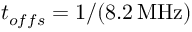<formula> <loc_0><loc_0><loc_500><loc_500>t _ { o f f s } = 1 / ( 8 . 2 \, M H z )</formula> 